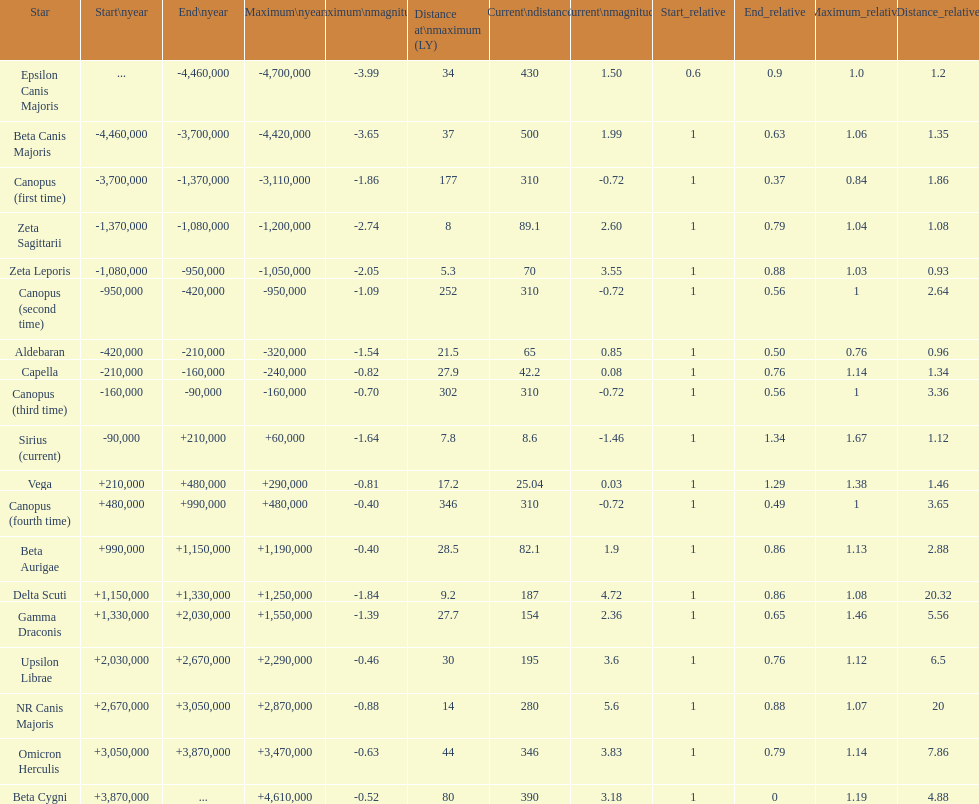How much farther (in ly) is epsilon canis majoris than zeta sagittarii? 26. 